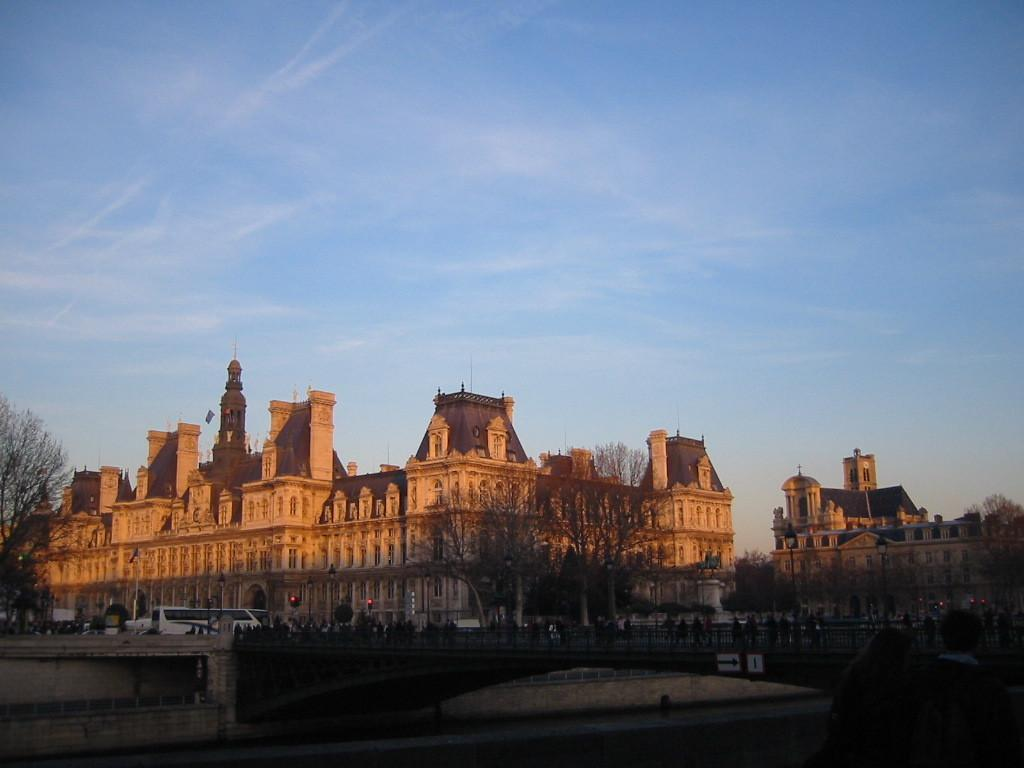How many people are in the image? There is a group of people in the image. What structure can be seen in the image? There is a bridge in the image. What natural element is present in the image? There is water in the image. What type of vegetation is visible in the image? There are trees in the image. What are the poles used for in the image? The poles are used to support the lights in the image. What type of transportation is present in the image? There are vehicles in the image. What type of man-made structures are visible in the image? There are buildings in the image. What can be seen in the background of the image? The sky is visible in the background of the image. How does the tramp help the group of people cross the bridge in the image? There is no tramp present in the image; it is a group of people, a bridge, and other elements mentioned in the facts. 